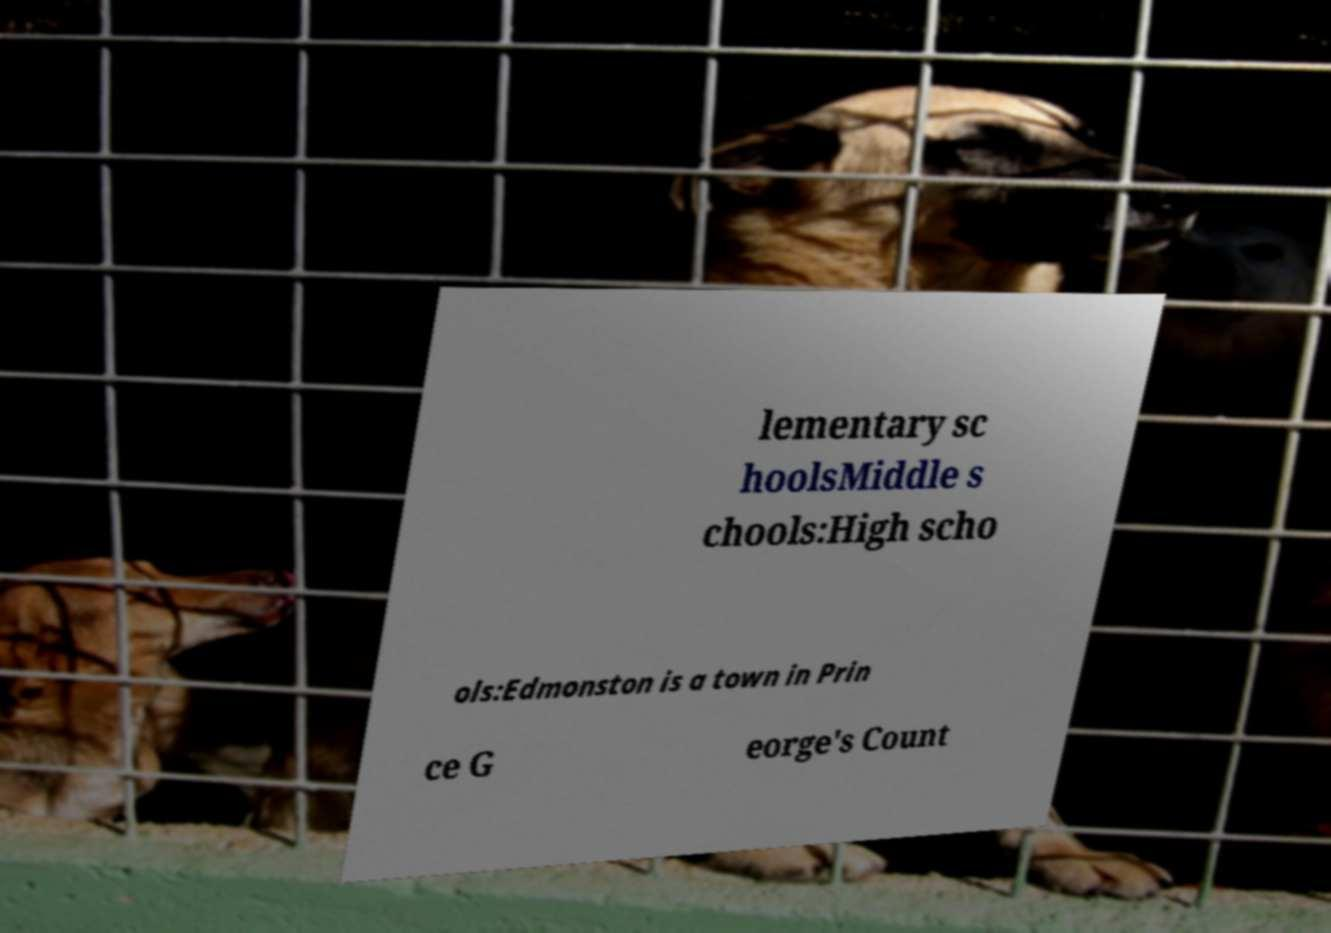Please identify and transcribe the text found in this image. lementary sc hoolsMiddle s chools:High scho ols:Edmonston is a town in Prin ce G eorge's Count 